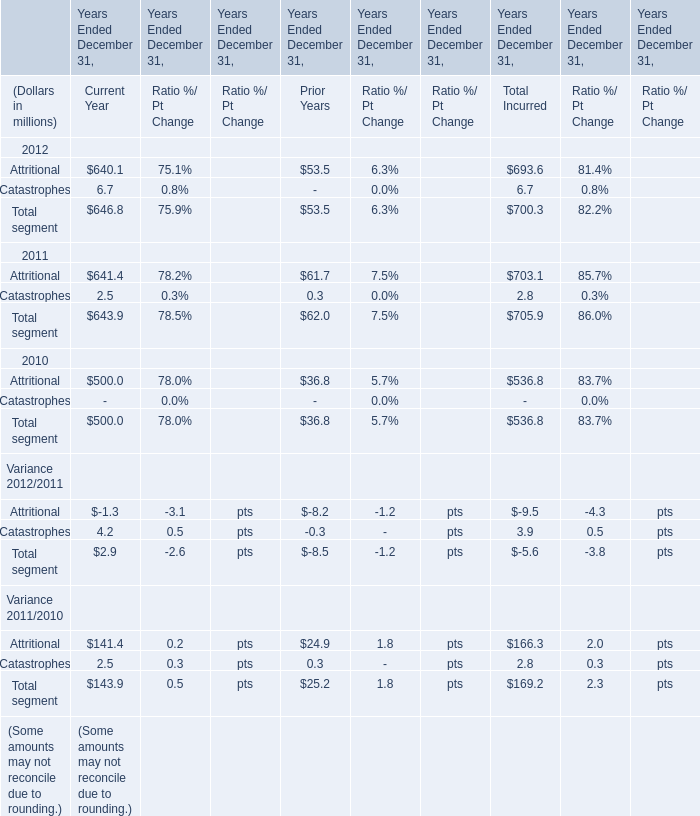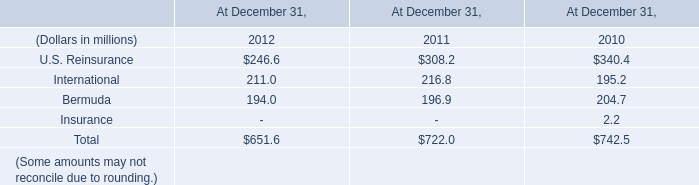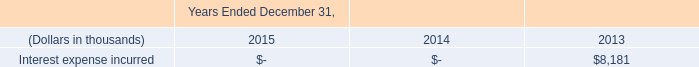what is the yearly interest incurred by the redeemed amount of junior subordinated debt , in thousands? 
Computations: (329897 * 6.2%)
Answer: 20453.614. 